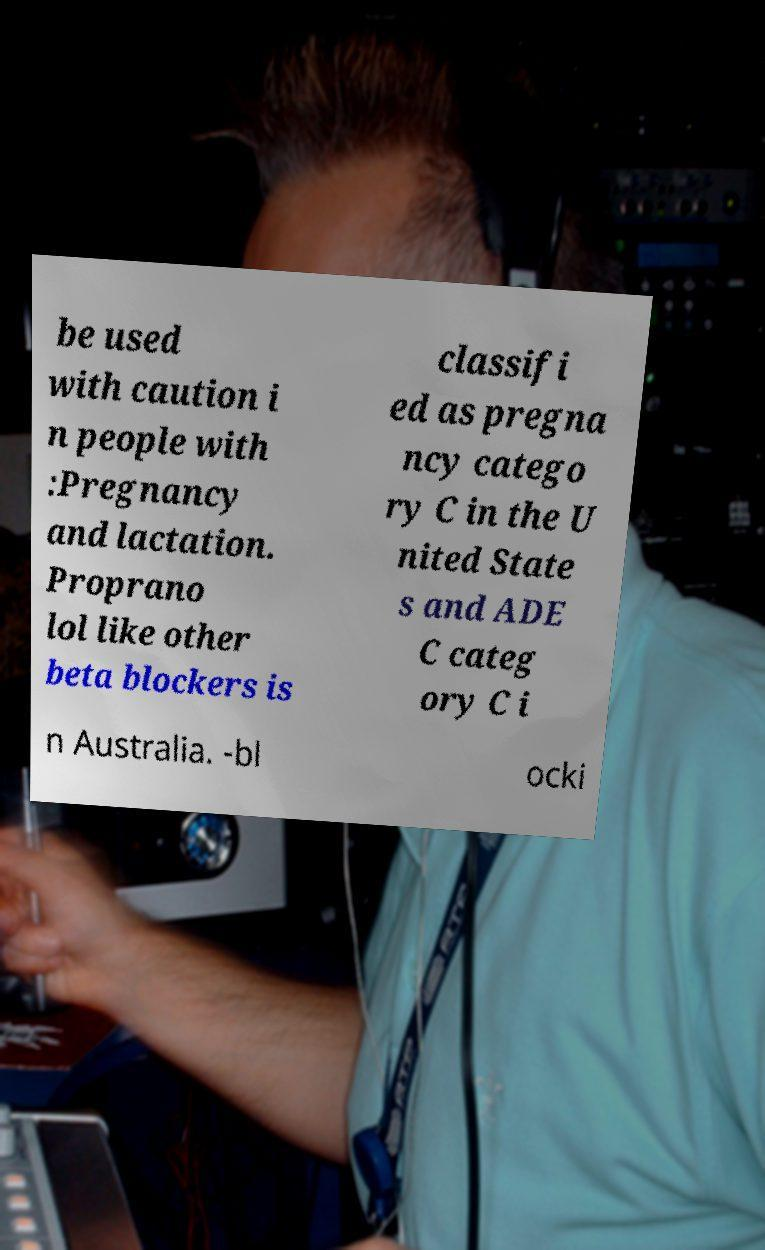For documentation purposes, I need the text within this image transcribed. Could you provide that? be used with caution i n people with :Pregnancy and lactation. Proprano lol like other beta blockers is classifi ed as pregna ncy catego ry C in the U nited State s and ADE C categ ory C i n Australia. -bl ocki 